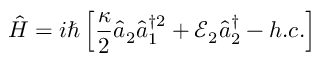Convert formula to latex. <formula><loc_0><loc_0><loc_500><loc_500>\hat { H } = i \hbar { \left } [ \frac { \kappa } { 2 } \hat { a } _ { 2 } \hat { a } _ { 1 } ^ { \dagger 2 } + \mathcal { E } _ { 2 } \hat { a } _ { 2 } ^ { \dagger } - h . c . \right ]</formula> 